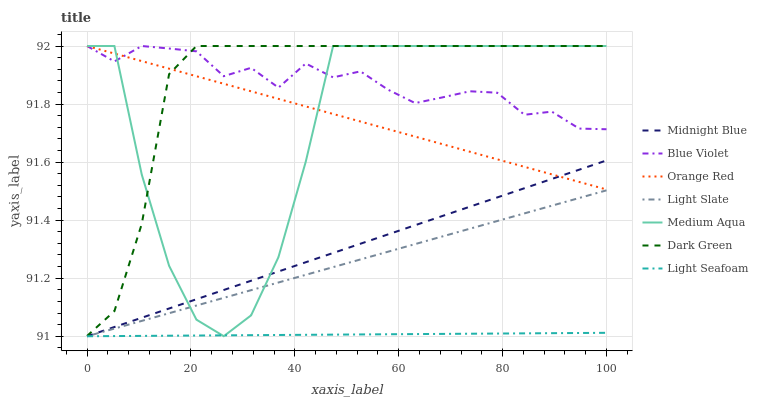Does Light Seafoam have the minimum area under the curve?
Answer yes or no. Yes. Does Dark Green have the maximum area under the curve?
Answer yes or no. Yes. Does Light Slate have the minimum area under the curve?
Answer yes or no. No. Does Light Slate have the maximum area under the curve?
Answer yes or no. No. Is Orange Red the smoothest?
Answer yes or no. Yes. Is Medium Aqua the roughest?
Answer yes or no. Yes. Is Light Slate the smoothest?
Answer yes or no. No. Is Light Slate the roughest?
Answer yes or no. No. Does Midnight Blue have the lowest value?
Answer yes or no. Yes. Does Medium Aqua have the lowest value?
Answer yes or no. No. Does Dark Green have the highest value?
Answer yes or no. Yes. Does Light Slate have the highest value?
Answer yes or no. No. Is Midnight Blue less than Dark Green?
Answer yes or no. Yes. Is Orange Red greater than Light Seafoam?
Answer yes or no. Yes. Does Light Seafoam intersect Medium Aqua?
Answer yes or no. Yes. Is Light Seafoam less than Medium Aqua?
Answer yes or no. No. Is Light Seafoam greater than Medium Aqua?
Answer yes or no. No. Does Midnight Blue intersect Dark Green?
Answer yes or no. No. 